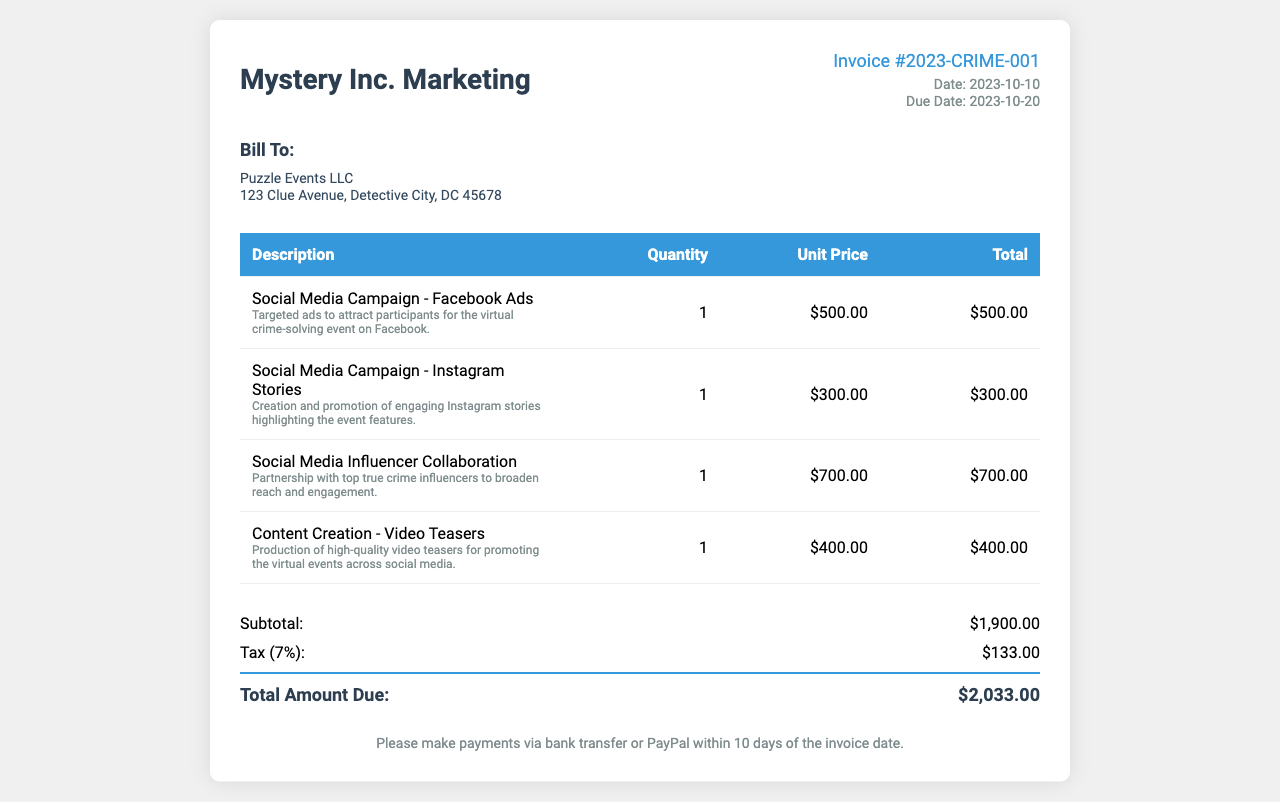What is the invoice number? The invoice number is located in the invoice details section, specifically marked on the document.
Answer: Invoice #2023-CRIME-001 What is the due date for the invoice? The due date is found in the dates section of the invoice details.
Answer: 2023-10-20 Who is the invoice billed to? The billing address indicates who the invoice is addressed to.
Answer: Puzzle Events LLC What is the total amount due? The total amount due is listed at the bottom of the invoice after the subtotal and tax calculations.
Answer: $2,033.00 How much was charged for the Instagram Stories campaign? The cost for the Instagram Stories campaign is noted in the details of the corresponding line item.
Answer: $300.00 What percentage is the tax applied to the subtotal? The tax percentage is indicated next to the tax amount in the invoice.
Answer: 7% What is one of the services included in the invoice? The line items in the invoice provide specific services rendered that are listed under the description column.
Answer: Social Media Campaign - Facebook Ads How many services are listed in the invoice? The total number of line items shows the count of services provided in the invoice.
Answer: 4 What payment methods are accepted according to the invoice? The invoice specifies the methods of payment in the payment terms section.
Answer: Bank transfer or PayPal 